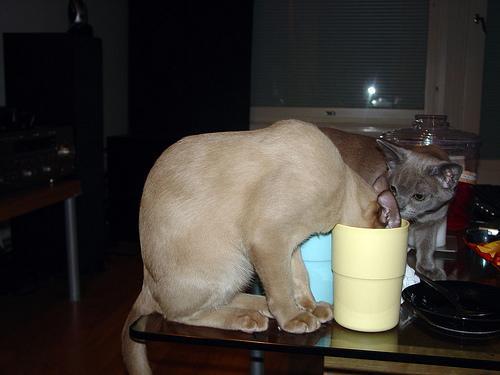How many cats are on the table?
Give a very brief answer. 2. How many cats can you see?
Give a very brief answer. 2. 